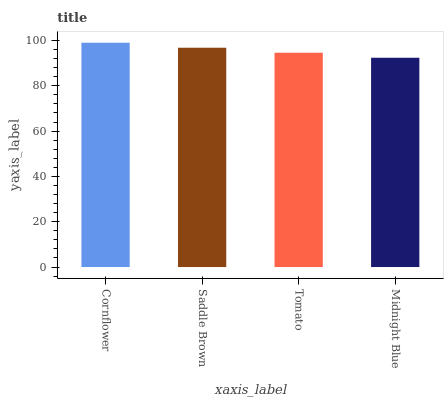Is Saddle Brown the minimum?
Answer yes or no. No. Is Saddle Brown the maximum?
Answer yes or no. No. Is Cornflower greater than Saddle Brown?
Answer yes or no. Yes. Is Saddle Brown less than Cornflower?
Answer yes or no. Yes. Is Saddle Brown greater than Cornflower?
Answer yes or no. No. Is Cornflower less than Saddle Brown?
Answer yes or no. No. Is Saddle Brown the high median?
Answer yes or no. Yes. Is Tomato the low median?
Answer yes or no. Yes. Is Cornflower the high median?
Answer yes or no. No. Is Midnight Blue the low median?
Answer yes or no. No. 